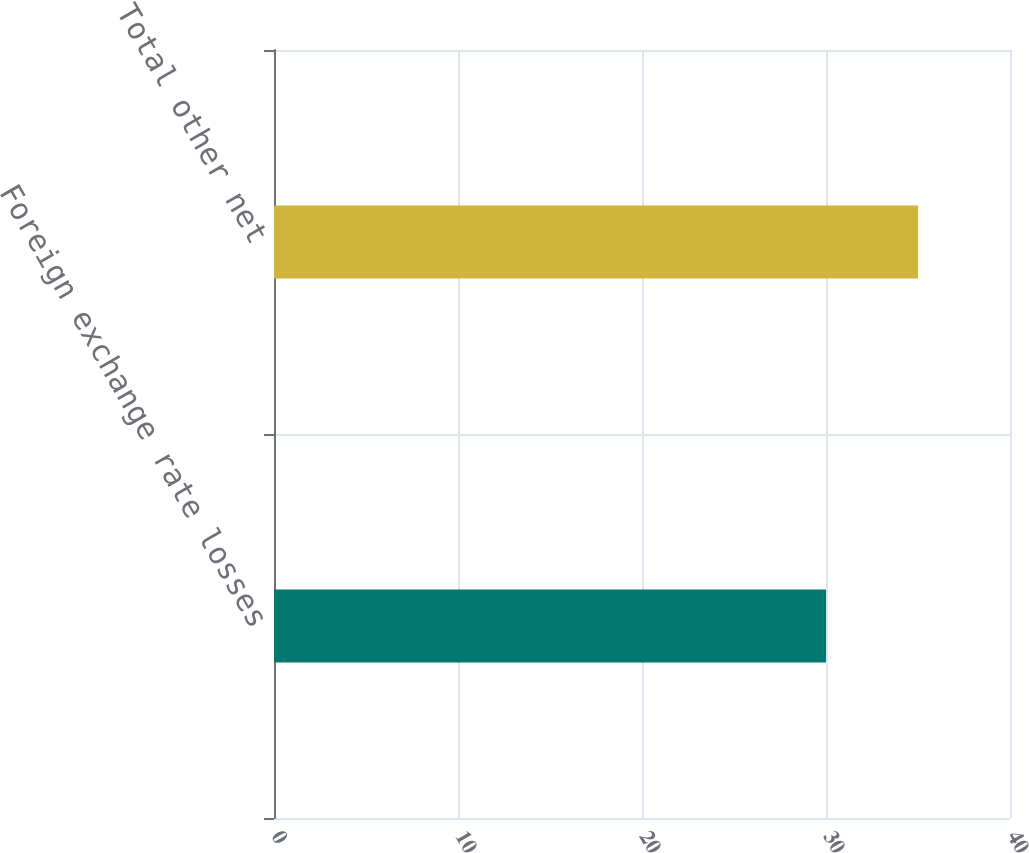Convert chart to OTSL. <chart><loc_0><loc_0><loc_500><loc_500><bar_chart><fcel>Foreign exchange rate losses<fcel>Total other net<nl><fcel>30<fcel>35<nl></chart> 